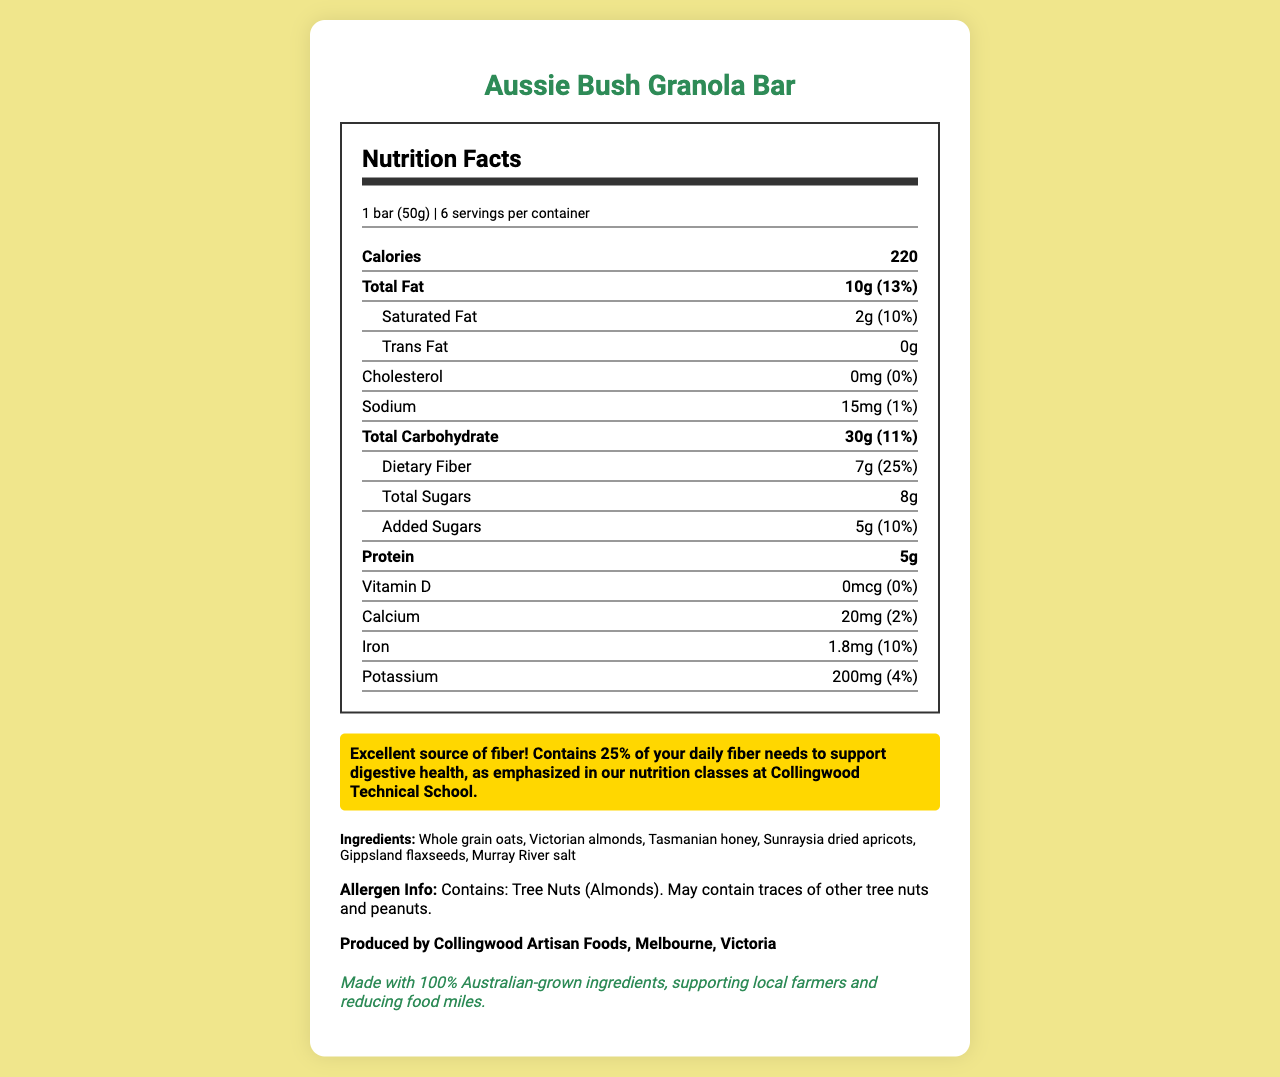what is the serving size? The serving size is listed at the beginning of the Nutrition Facts Label under the serving information section.
Answer: 1 bar (50g) how much dietary fiber is in one serving? The amount of dietary fiber per serving is listed under the Total Carbohydrate section as 7g.
Answer: 7g what is the daily value percentage of dietary fiber per serving? The daily value percentage of dietary fiber per serving is mentioned right next to the amount of dietary fiber, listed as 25%.
Answer: 25% who is the manufacturer of this product? The manufacturer information is provided at the bottom of the document.
Answer: Collingwood Artisan Foods, Melbourne, Victoria what percentage of your daily iron needs does one serving provide? The percentage of daily iron needs provided by one serving is listed under the Iron section as 10%.
Answer: 10% how many servings are in each container of the granola bar? A. 4 B. 6 C. 8 D. 12 The number of servings per container is mentioned at the beginning of the Nutrition Facts Label as 6.
Answer: B which of the following ingredients is not listed in the granola bar ingredients? I. Gippsland flaxseeds II. Tasmanian honey III. Sunraysia dried apricots IV. Raw cane sugar The ingredients listed include Whole grain oats, Victorian almonds, Tasmanian honey, Sunraysia dried apricots, Gippsland flaxseeds, and Murray River salt, but not Raw cane sugar.
Answer: IV does the product contain added sugars? The document lists that the granola bar contains added sugars with an amount of 5g and a daily value percentage of 10%.
Answer: Yes summarize the main idea of the document. The summary involves extracting key points such as nutritional content, ingredients, allergen details, and sustainability emphasis.
Answer: The document provides detailed nutrition facts for the "Aussie Bush Granola Bar." It includes serving size, calories, amounts of various nutrients, ingredients, allergen information, manufacturer details, and a note emphasizing the fiber content's health benefits. what is the exact amount of vitamin D in one serving of the granola bar? The document specifies the amount of vitamin D in one serving as 0mcg.
Answer: 0mcg what is the source of the nuts used in this granola bar? The ingredient list mentions Victorian almonds specifically as the source of the nuts used in the granola bar.
Answer: Victorian almonds how much total fat does one serving have? The amount of total fat per serving is indicated in the Fat section as 10g with a daily value percentage of 13%.
Answer: 10g what is the purpose of the highlighted section about fiber? The highlighted section explains the health benefits of the fiber content in the granola bar, linking it to nutritional teachings at Collingwood Technical School.
Answer: To emphasize that the granola bar is an excellent source of fiber, providing 25% of daily fiber needs and supporting digestive health. does the granola bar meet 100% of the daily calcium needs? The document lists that one serving provides only 2% of the daily calcium needs.
Answer: No how was this document generated? The document doesn't provide any details about its generation process.
Answer: Not enough information 